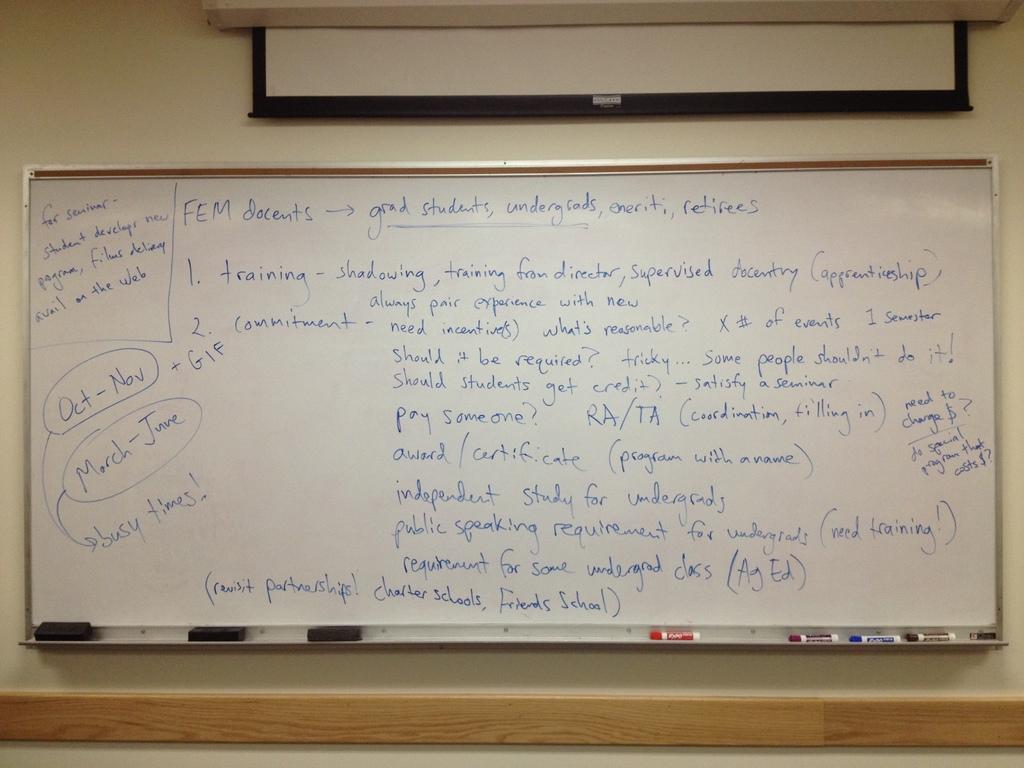Which stretch of months are going to be the busy times?
Make the answer very short. March-june. What is the topic for number one?
Make the answer very short. Training. 